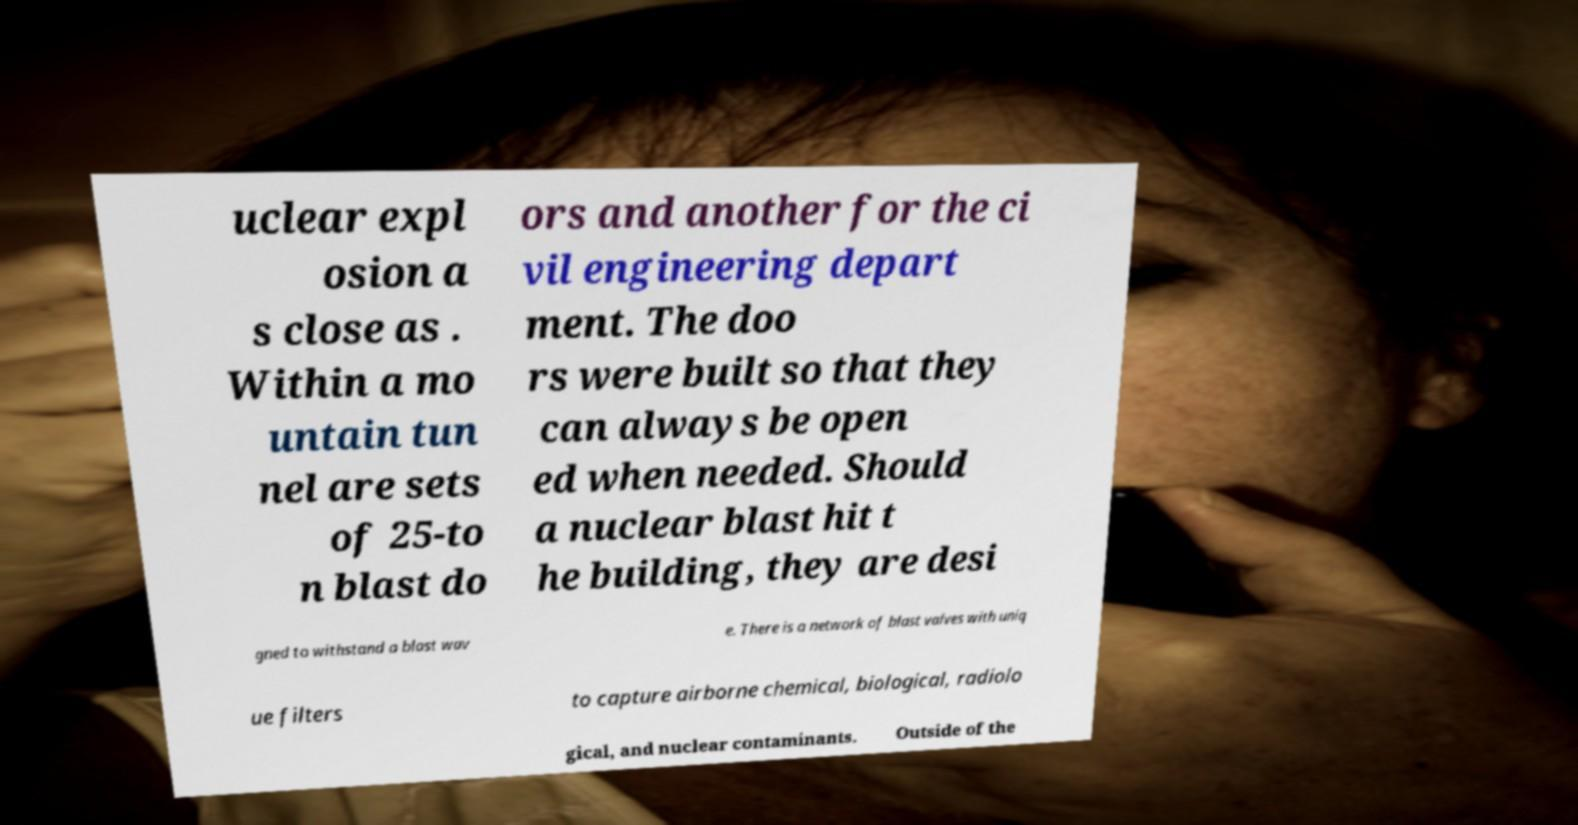Please identify and transcribe the text found in this image. uclear expl osion a s close as . Within a mo untain tun nel are sets of 25-to n blast do ors and another for the ci vil engineering depart ment. The doo rs were built so that they can always be open ed when needed. Should a nuclear blast hit t he building, they are desi gned to withstand a blast wav e. There is a network of blast valves with uniq ue filters to capture airborne chemical, biological, radiolo gical, and nuclear contaminants. Outside of the 